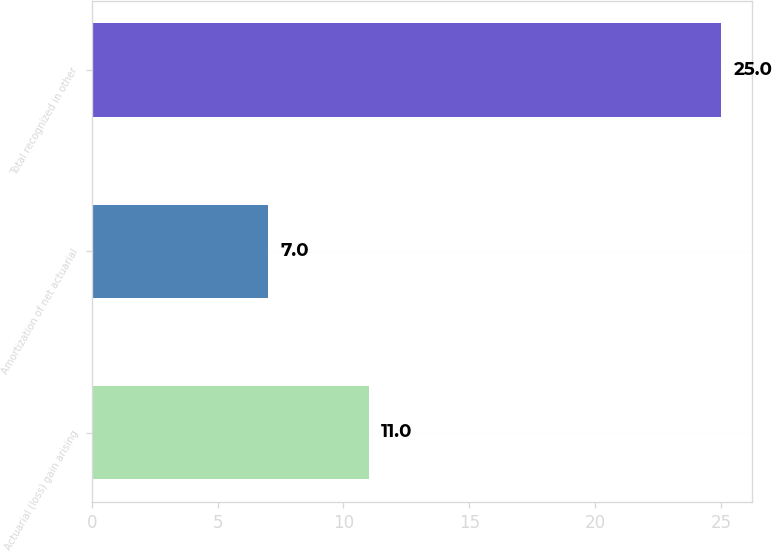Convert chart to OTSL. <chart><loc_0><loc_0><loc_500><loc_500><bar_chart><fcel>Actuarial (loss) gain arising<fcel>Amortization of net actuarial<fcel>Total recognized in other<nl><fcel>11<fcel>7<fcel>25<nl></chart> 